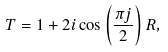<formula> <loc_0><loc_0><loc_500><loc_500>T = 1 + 2 i \cos \left ( \frac { \pi j } { 2 } \right ) R ,</formula> 